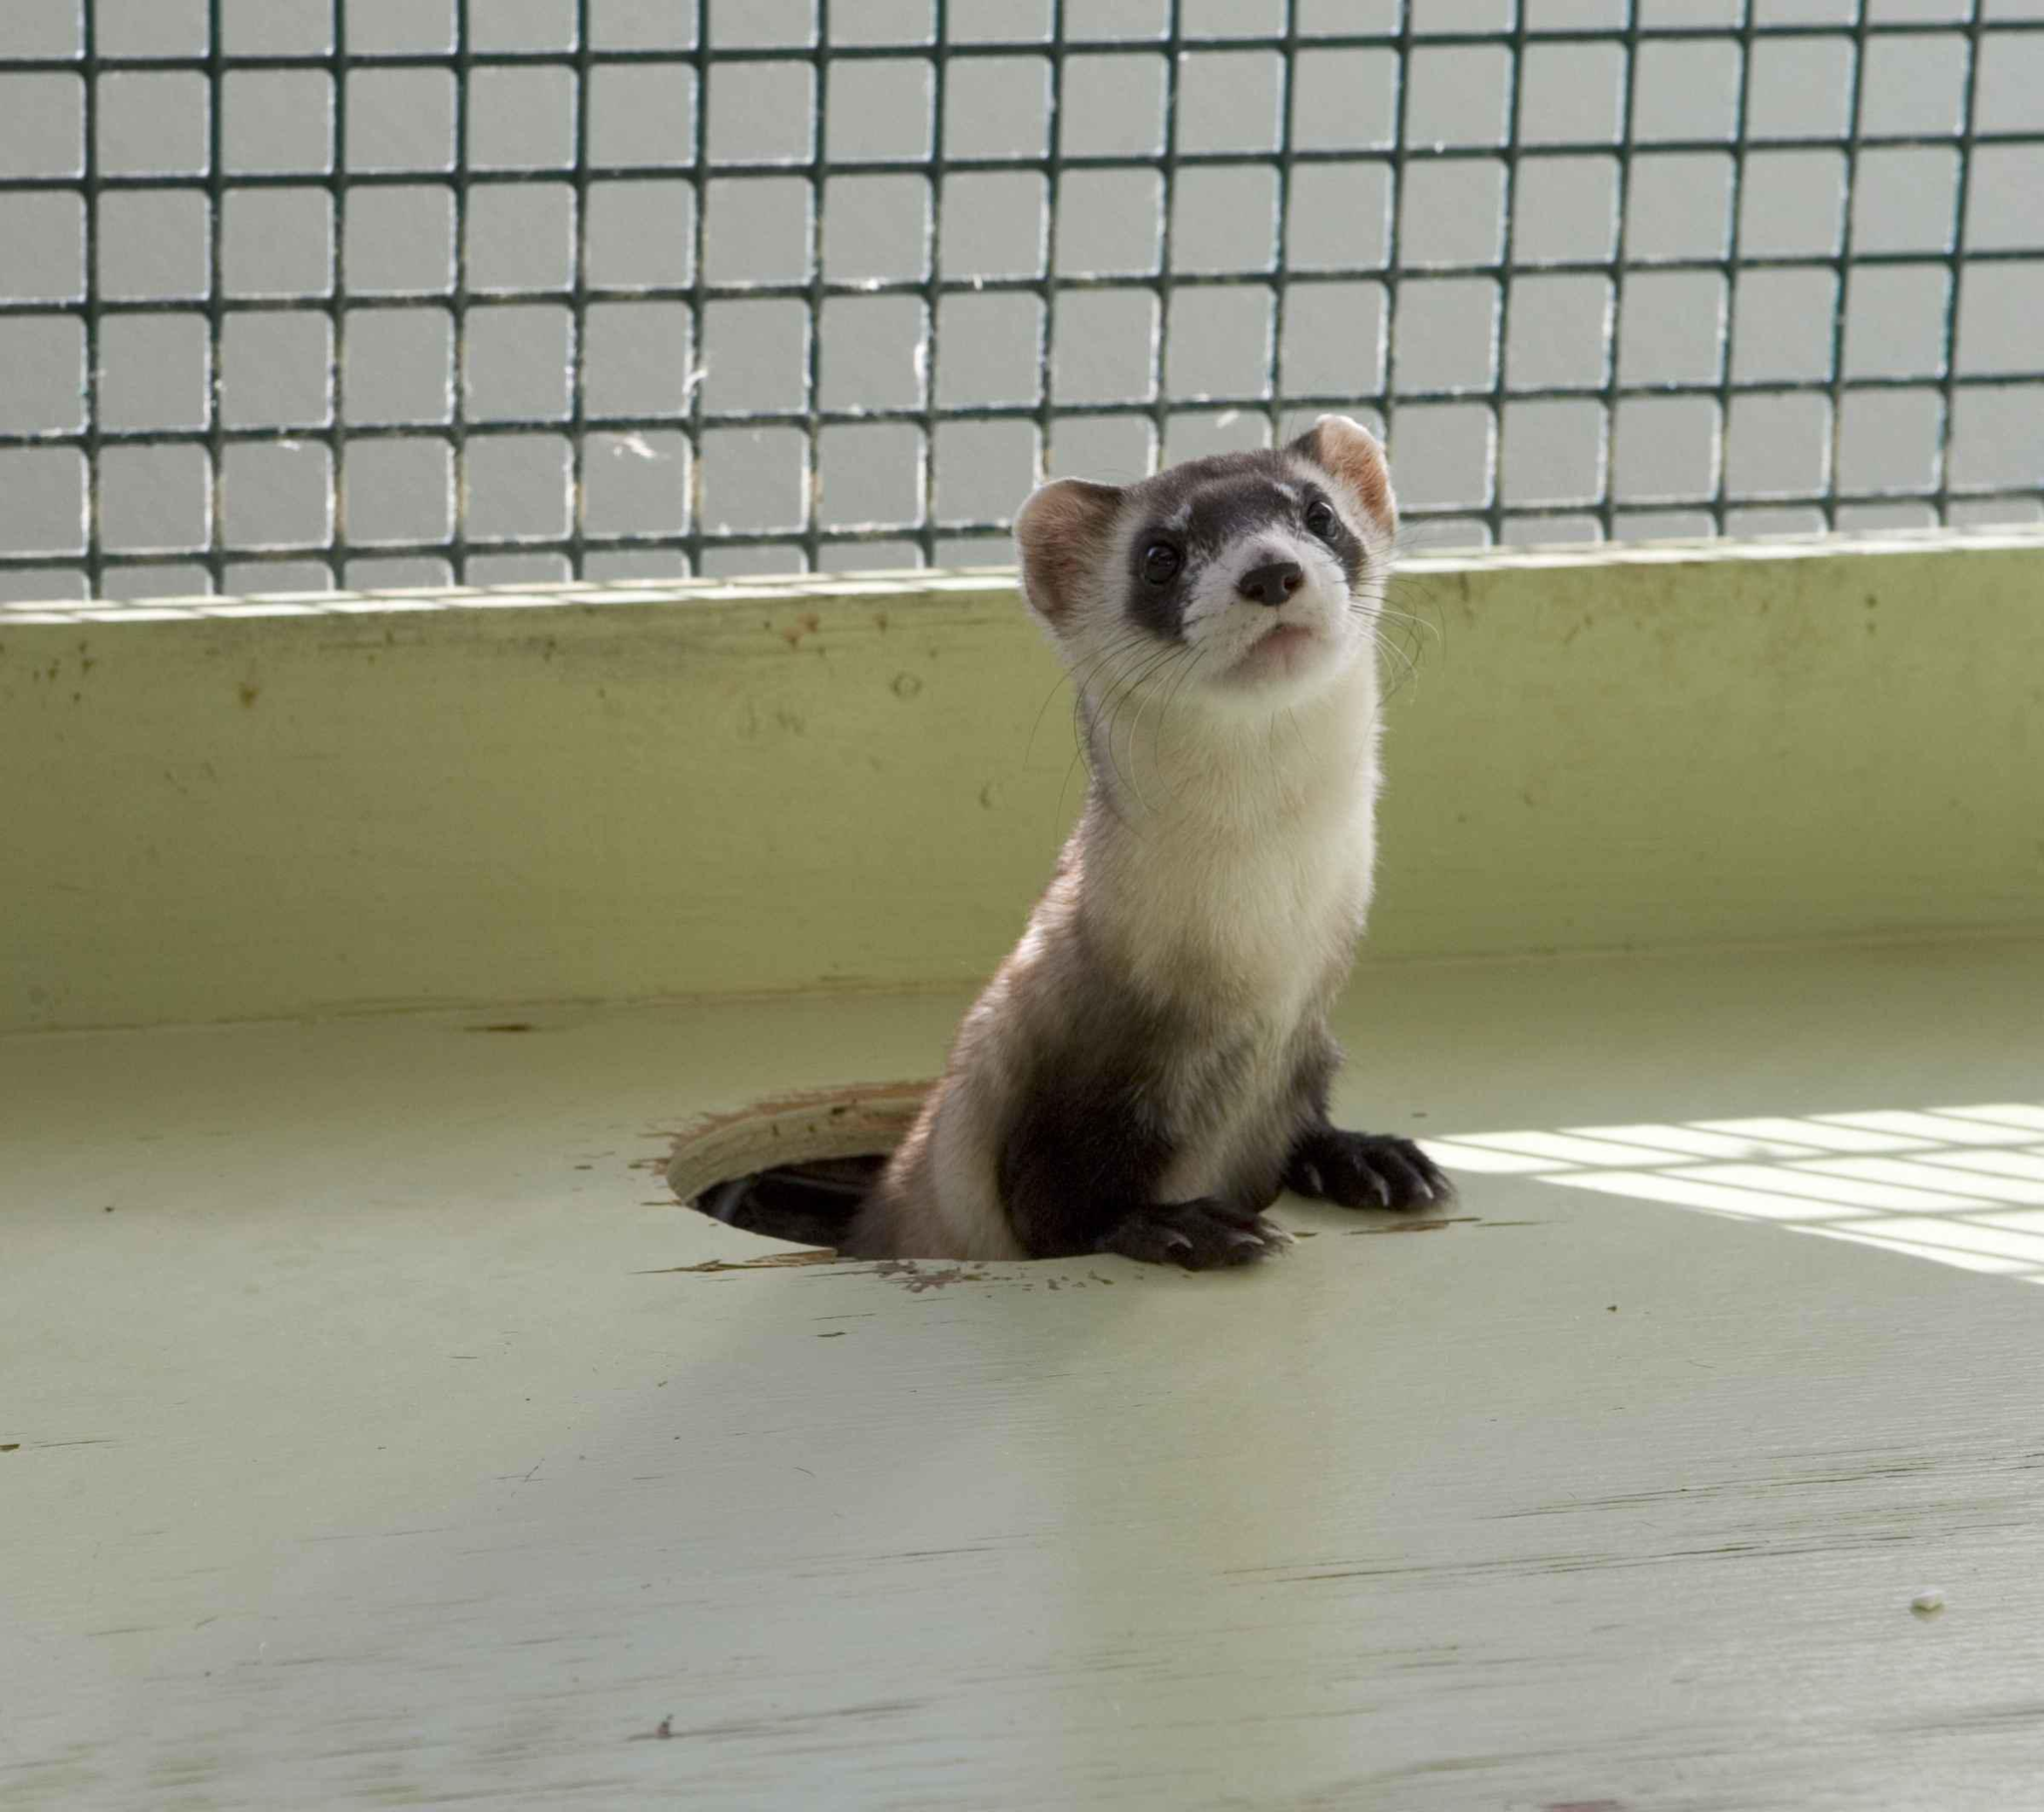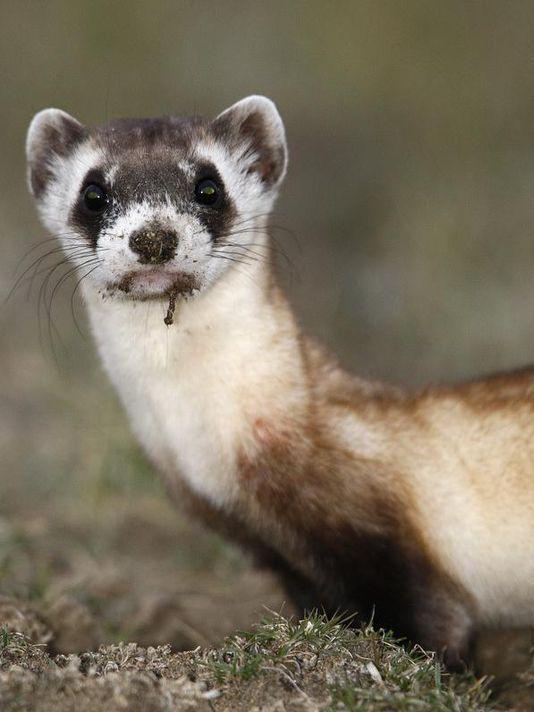The first image is the image on the left, the second image is the image on the right. Examine the images to the left and right. Is the description "There is one ferret emerging from a hole and another ferret standing on some dirt." accurate? Answer yes or no. Yes. The first image is the image on the left, the second image is the image on the right. For the images displayed, is the sentence "A ferret is popping up through a hole inside a metal wire cage." factually correct? Answer yes or no. Yes. 